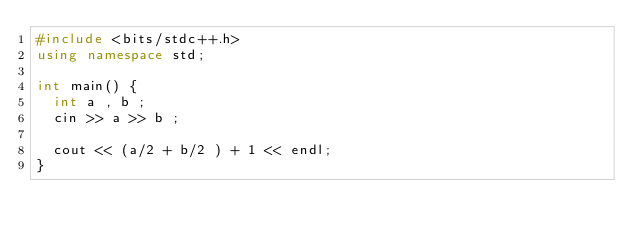Convert code to text. <code><loc_0><loc_0><loc_500><loc_500><_C++_>#include <bits/stdc++.h>
using namespace std;

int main() {
  int a , b ;
  cin >> a >> b ;
 
  cout << (a/2 + b/2 ) + 1 << endl;
}
</code> 